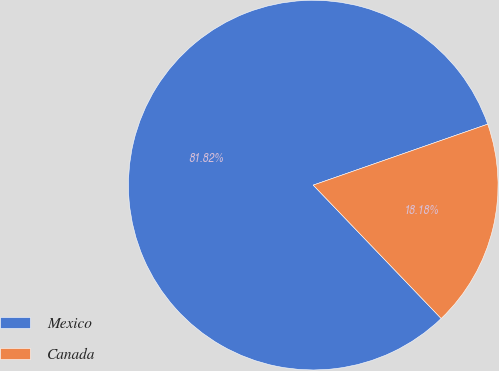Convert chart to OTSL. <chart><loc_0><loc_0><loc_500><loc_500><pie_chart><fcel>Mexico<fcel>Canada<nl><fcel>81.82%<fcel>18.18%<nl></chart> 